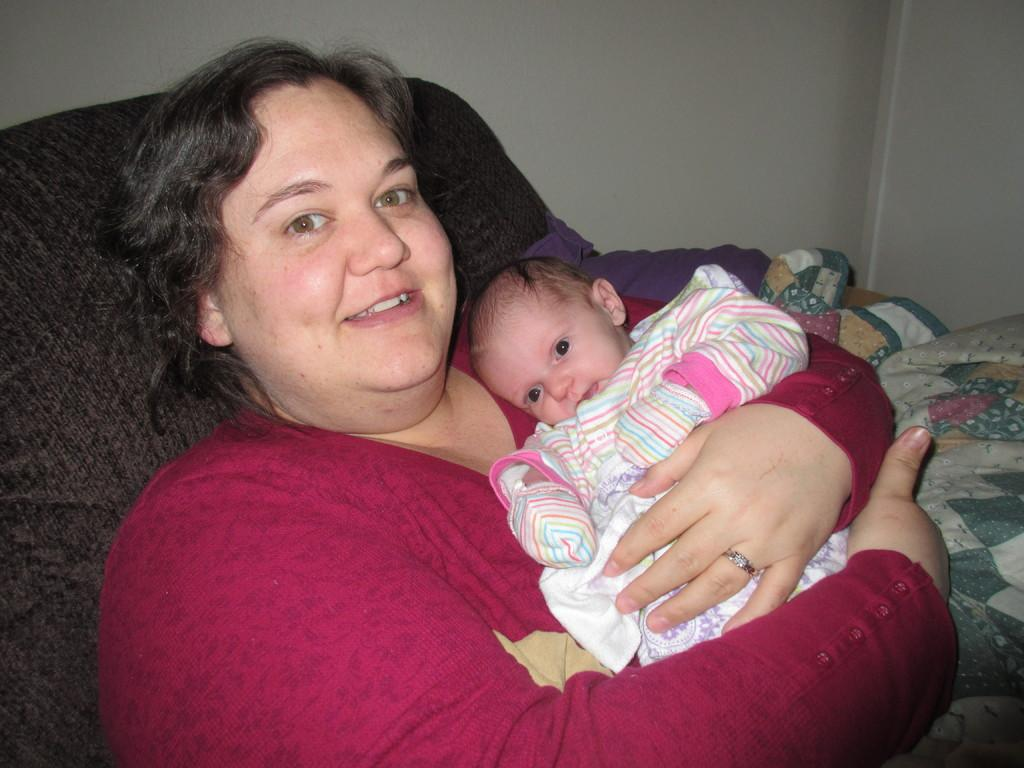What is the person in the image holding? The person is holding a baby in the image. What is the person wearing? The person is wearing a red dress. What can be seen in the background of the image? There is a brown color bed in the background of the image. What color is the wall in the image? The wall is in cream color. What type of mint can be seen growing on the wall in the image? There is no mint present in the image; the wall is in cream color. How many pies are visible on the bed in the image? There are no pies present in the image; there is a brown color bed in the background. 